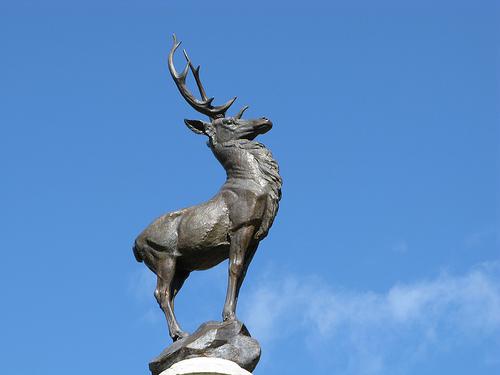<image>
Can you confirm if the sky is behind the statue? Yes. From this viewpoint, the sky is positioned behind the statue, with the statue partially or fully occluding the sky. 